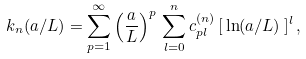<formula> <loc_0><loc_0><loc_500><loc_500>k _ { n } ( a / L ) = \sum _ { p = 1 } ^ { \infty } \left ( \frac { a } { L } \right ) ^ { p } \, \sum _ { l = 0 } ^ { n } c _ { p l } ^ { ( n ) } \, [ \, \ln ( a / L ) \, ] ^ { l } \, ,</formula> 